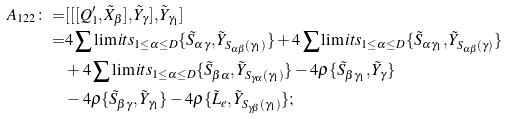Convert formula to latex. <formula><loc_0><loc_0><loc_500><loc_500>A _ { 1 2 2 } \colon = & [ [ [ Q _ { 1 } ^ { \prime } , \tilde { X } _ { \beta } ] , \tilde { Y } _ { \gamma } ] , \tilde { Y } _ { \gamma _ { 1 } } ] \\ = & 4 \sum \lim i t s _ { 1 \leq \alpha \leq D } \{ \tilde { S } _ { \alpha \gamma } , \tilde { Y } _ { S _ { \alpha \beta } ( \gamma _ { 1 } ) } \} + 4 \sum \lim i t s _ { 1 \leq \alpha \leq D } \{ \tilde { S } _ { \alpha \gamma _ { 1 } } , \tilde { Y } _ { S _ { \alpha \beta } ( \gamma ) } \} \\ & + 4 \sum \lim i t s _ { 1 \leq \alpha \leq D } \{ \tilde { S } _ { \beta \alpha } , \tilde { Y } _ { S _ { \gamma \alpha } ( \gamma _ { 1 } ) } \} - 4 \rho \{ \tilde { S } _ { \beta \gamma _ { 1 } } , \tilde { Y } _ { \gamma } \} \\ & - 4 \rho \{ \tilde { S } _ { \beta \gamma } , \tilde { Y } _ { \gamma _ { 1 } } \} - 4 \rho \{ \tilde { L } _ { e } , \tilde { Y } _ { S _ { \gamma \beta } ( \gamma _ { 1 } ) } \} ;</formula> 